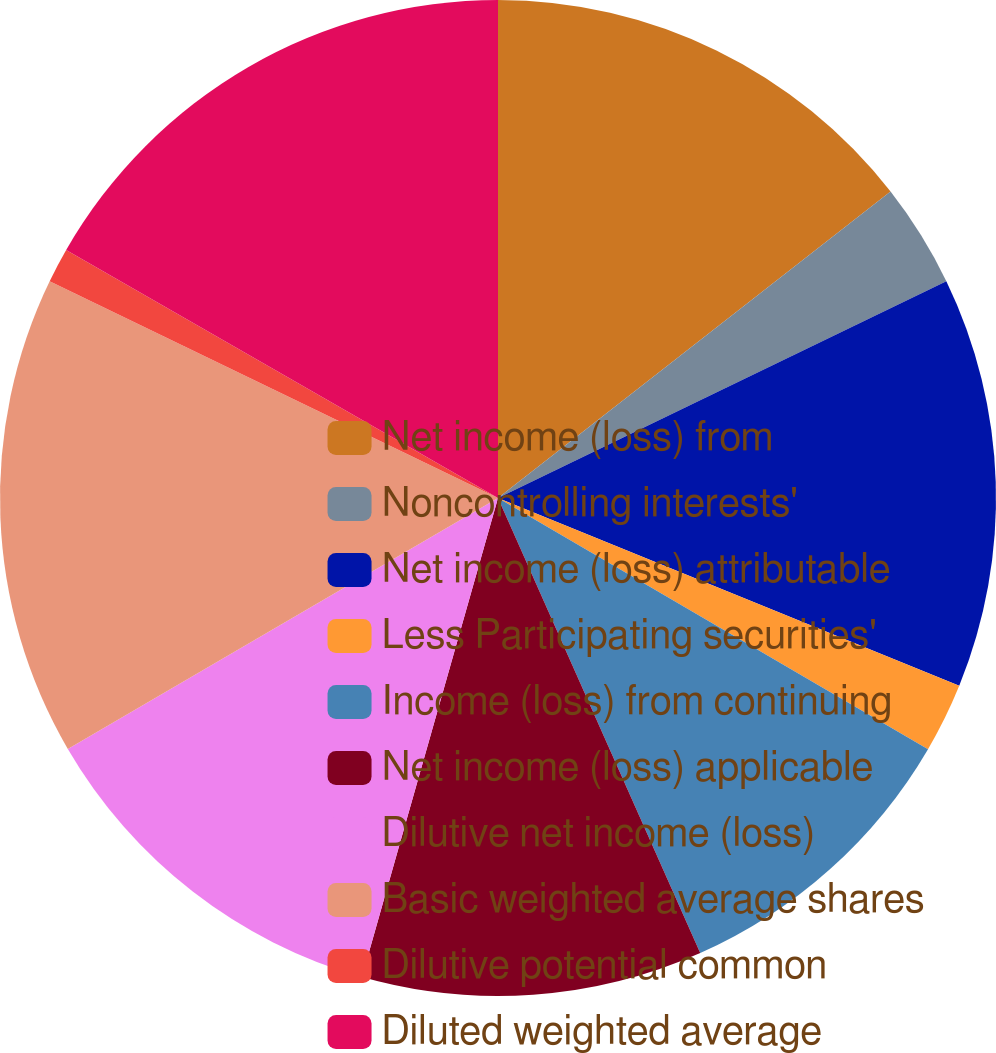<chart> <loc_0><loc_0><loc_500><loc_500><pie_chart><fcel>Net income (loss) from<fcel>Noncontrolling interests'<fcel>Net income (loss) attributable<fcel>Less Participating securities'<fcel>Income (loss) from continuing<fcel>Net income (loss) applicable<fcel>Dilutive net income (loss)<fcel>Basic weighted average shares<fcel>Dilutive potential common<fcel>Diluted weighted average<nl><fcel>14.45%<fcel>3.38%<fcel>13.32%<fcel>2.26%<fcel>9.93%<fcel>11.06%<fcel>12.19%<fcel>15.57%<fcel>1.13%<fcel>16.7%<nl></chart> 